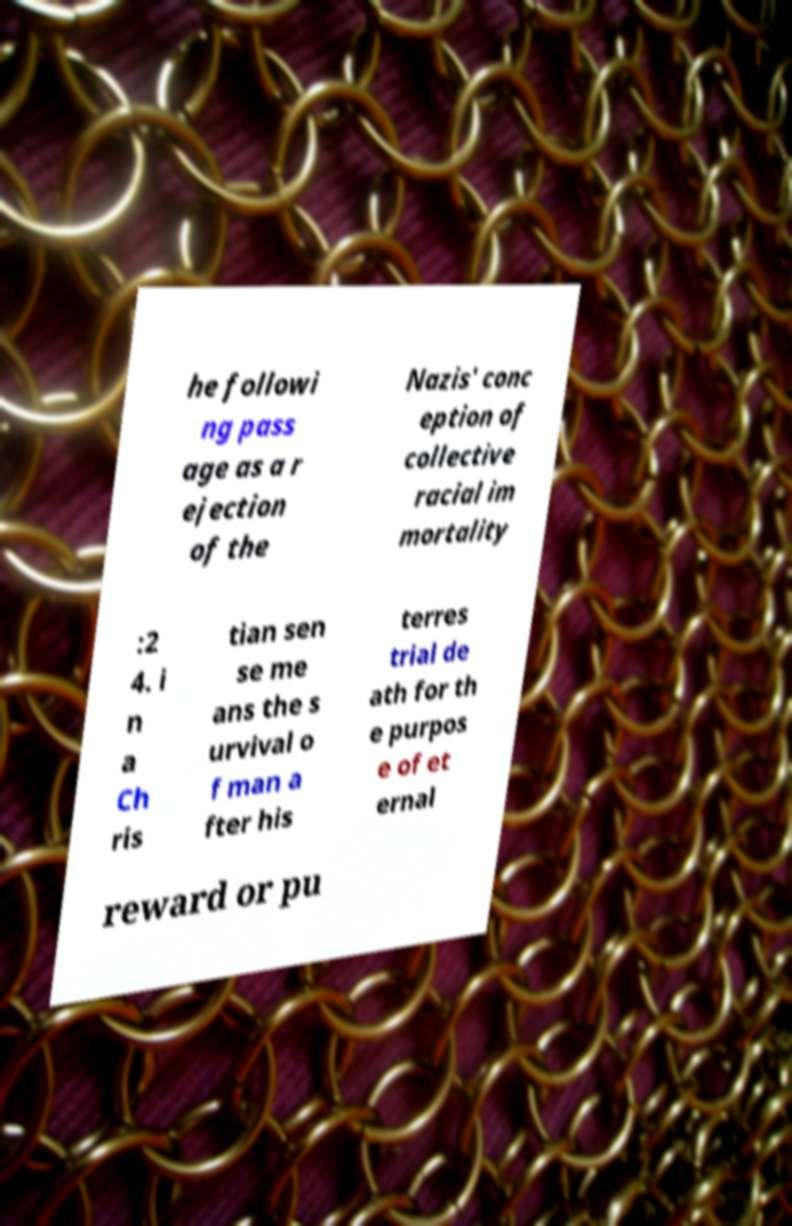There's text embedded in this image that I need extracted. Can you transcribe it verbatim? he followi ng pass age as a r ejection of the Nazis' conc eption of collective racial im mortality :2 4. i n a Ch ris tian sen se me ans the s urvival o f man a fter his terres trial de ath for th e purpos e of et ernal reward or pu 